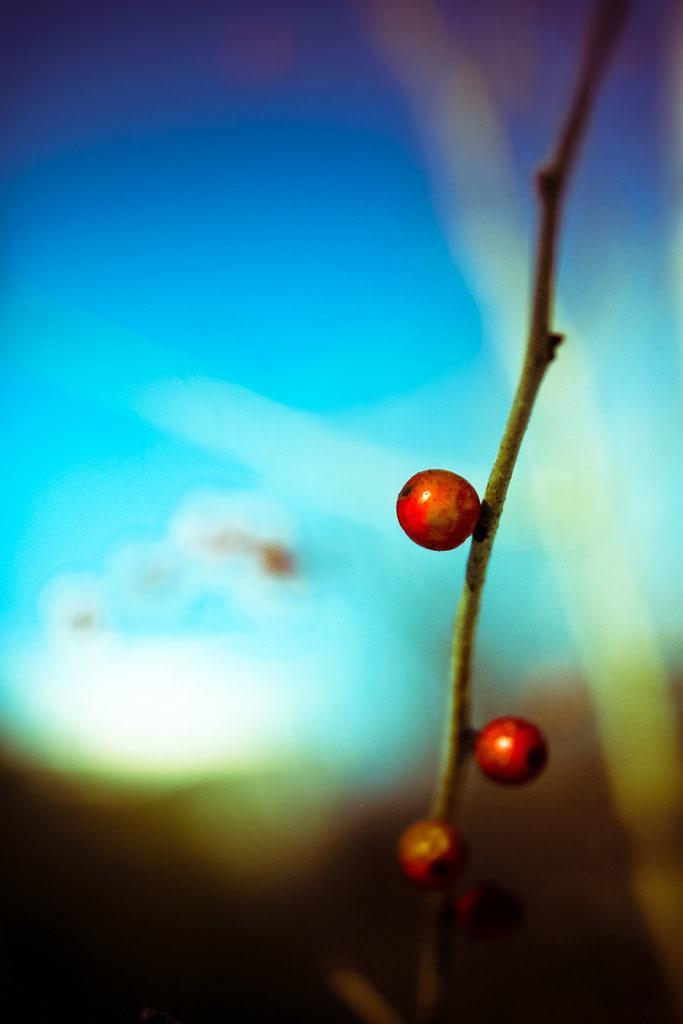Can you describe this image briefly? There is a plant having fruits. In the background, there is a sky and other objects. 